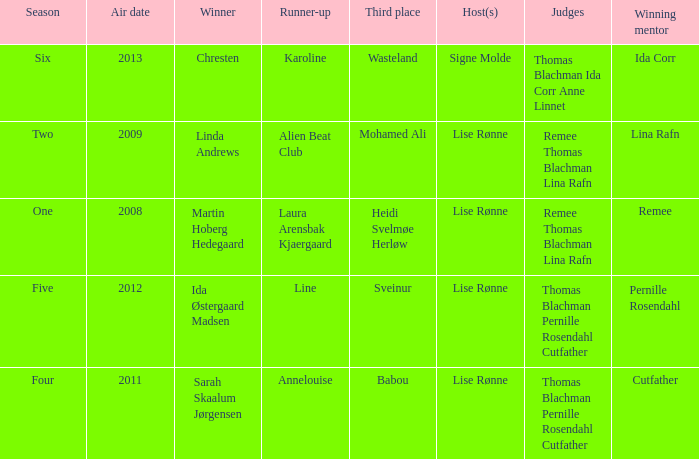Who was the runner-up in season five? Line. Help me parse the entirety of this table. {'header': ['Season', 'Air date', 'Winner', 'Runner-up', 'Third place', 'Host(s)', 'Judges', 'Winning mentor'], 'rows': [['Six', '2013', 'Chresten', 'Karoline', 'Wasteland', 'Signe Molde', 'Thomas Blachman Ida Corr Anne Linnet', 'Ida Corr'], ['Two', '2009', 'Linda Andrews', 'Alien Beat Club', 'Mohamed Ali', 'Lise Rønne', 'Remee Thomas Blachman Lina Rafn', 'Lina Rafn'], ['One', '2008', 'Martin Hoberg Hedegaard', 'Laura Arensbak Kjaergaard', 'Heidi Svelmøe Herløw', 'Lise Rønne', 'Remee Thomas Blachman Lina Rafn', 'Remee'], ['Five', '2012', 'Ida Østergaard Madsen', 'Line', 'Sveinur', 'Lise Rønne', 'Thomas Blachman Pernille Rosendahl Cutfather', 'Pernille Rosendahl'], ['Four', '2011', 'Sarah Skaalum Jørgensen', 'Annelouise', 'Babou', 'Lise Rønne', 'Thomas Blachman Pernille Rosendahl Cutfather', 'Cutfather']]} 